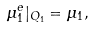<formula> <loc_0><loc_0><loc_500><loc_500>\mu _ { 1 } ^ { e } | _ { Q _ { 1 } } = \mu _ { 1 } ,</formula> 